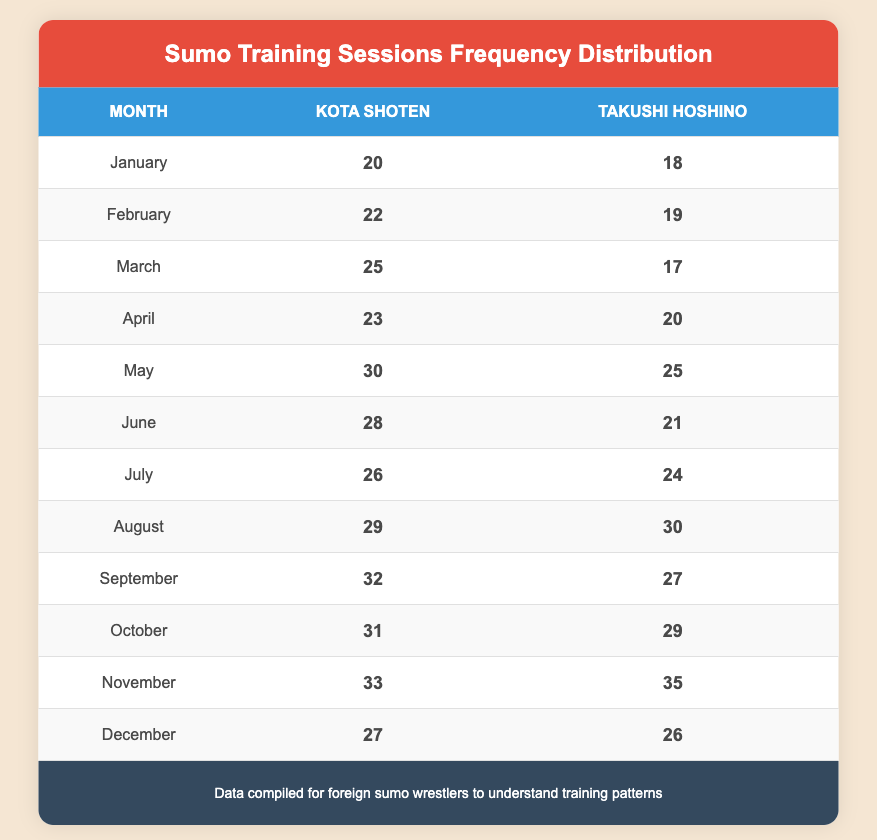What was the maximum number of sessions attended by Kota Shoten in a single month? Looking at the table, I find that Kota Shoten attended a maximum of 33 sessions in November.
Answer: 33 How many sessions did Takushi Hoshino attend in August? The table shows that Takushi Hoshino attended 30 sessions in August.
Answer: 30 Which month did Kota Shoten attend the most training sessions? By reviewing the data, it is clear that Kota Shoten attended the most sessions in November, with 33 sessions.
Answer: November What is the average number of sessions attended by Takushi Hoshino across all months? First, sum the sessions attended by Takushi Hoshino: (18 + 19 + 17 + 20 + 25 + 21 + 24 + 30 + 27 + 29 + 35 + 26) =  21.75, divided by the 12 months gives approx. 25.5 sessions per month.
Answer: 25.5 Did Kota Shoten attend more sessions than Takushi Hoshino in January? Comparing the January data, Kota Shoten attended 20 sessions and Takushi Hoshino attended 18 sessions, indicating that Kota Shoten attended more.
Answer: Yes What is the difference in sessions attended by Kota Shoten and Takushi Hoshino in May? Kota Shoten attended 30 sessions and Takushi Hoshino attended 25 sessions in May, so the difference is 30 - 25 = 5 sessions.
Answer: 5 In which month did both wrestlers have the exact same number of training sessions? A careful look at the table reveals that there are no months where both wrestlers attended the same number of sessions.
Answer: None What was the total number of training sessions attended by both wrestlers in December? Summing the December sessions, Kota Shoten attended 27 and Takushi Hoshino attended 26; therefore, the total is 27 + 26 = 53 sessions.
Answer: 53 Which wrestler had more training sessions overall? To determine this, I sum the sessions for each wrestler: Kota Shoten total is 20 + 22 + 25 + 23 + 30 + 28 + 26 + 29 + 32 + 31 + 33 + 27 =  342. Takushi Hoshino total is 18 + 19 + 17 + 20 + 25 + 21 + 24 + 30 + 27 + 29 + 35 + 26 =  177; thus, Kota Shoten had more sessions.
Answer: Kota Shoten 